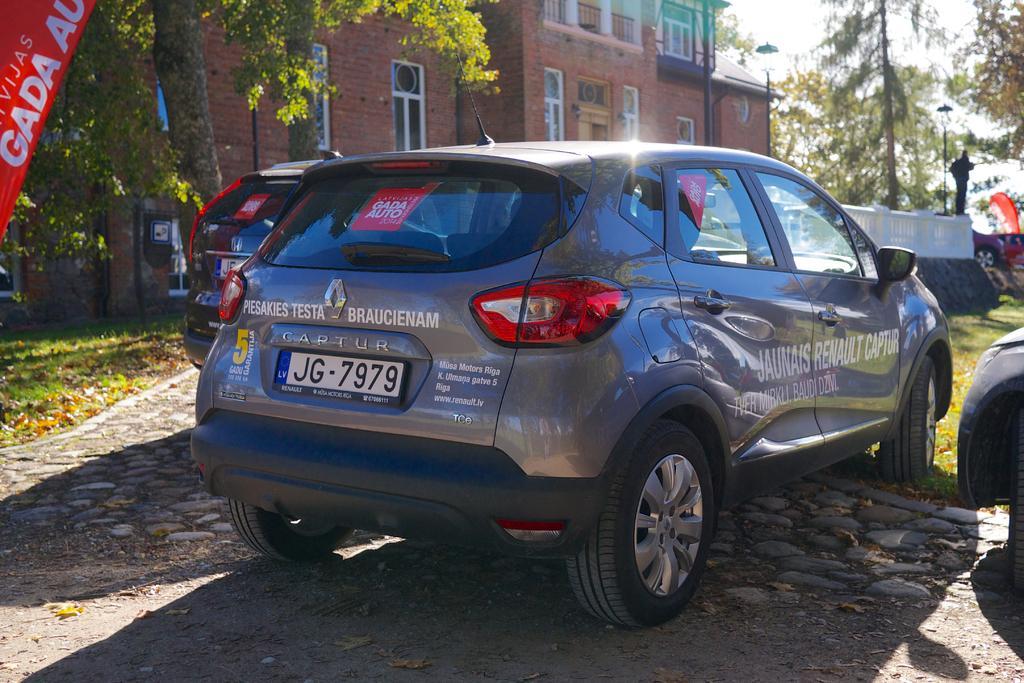Describe this image in one or two sentences. We can see cars on the surface,banner,grass and leaves. In the background we can see building,trees,poles,fence,windows and sky. 